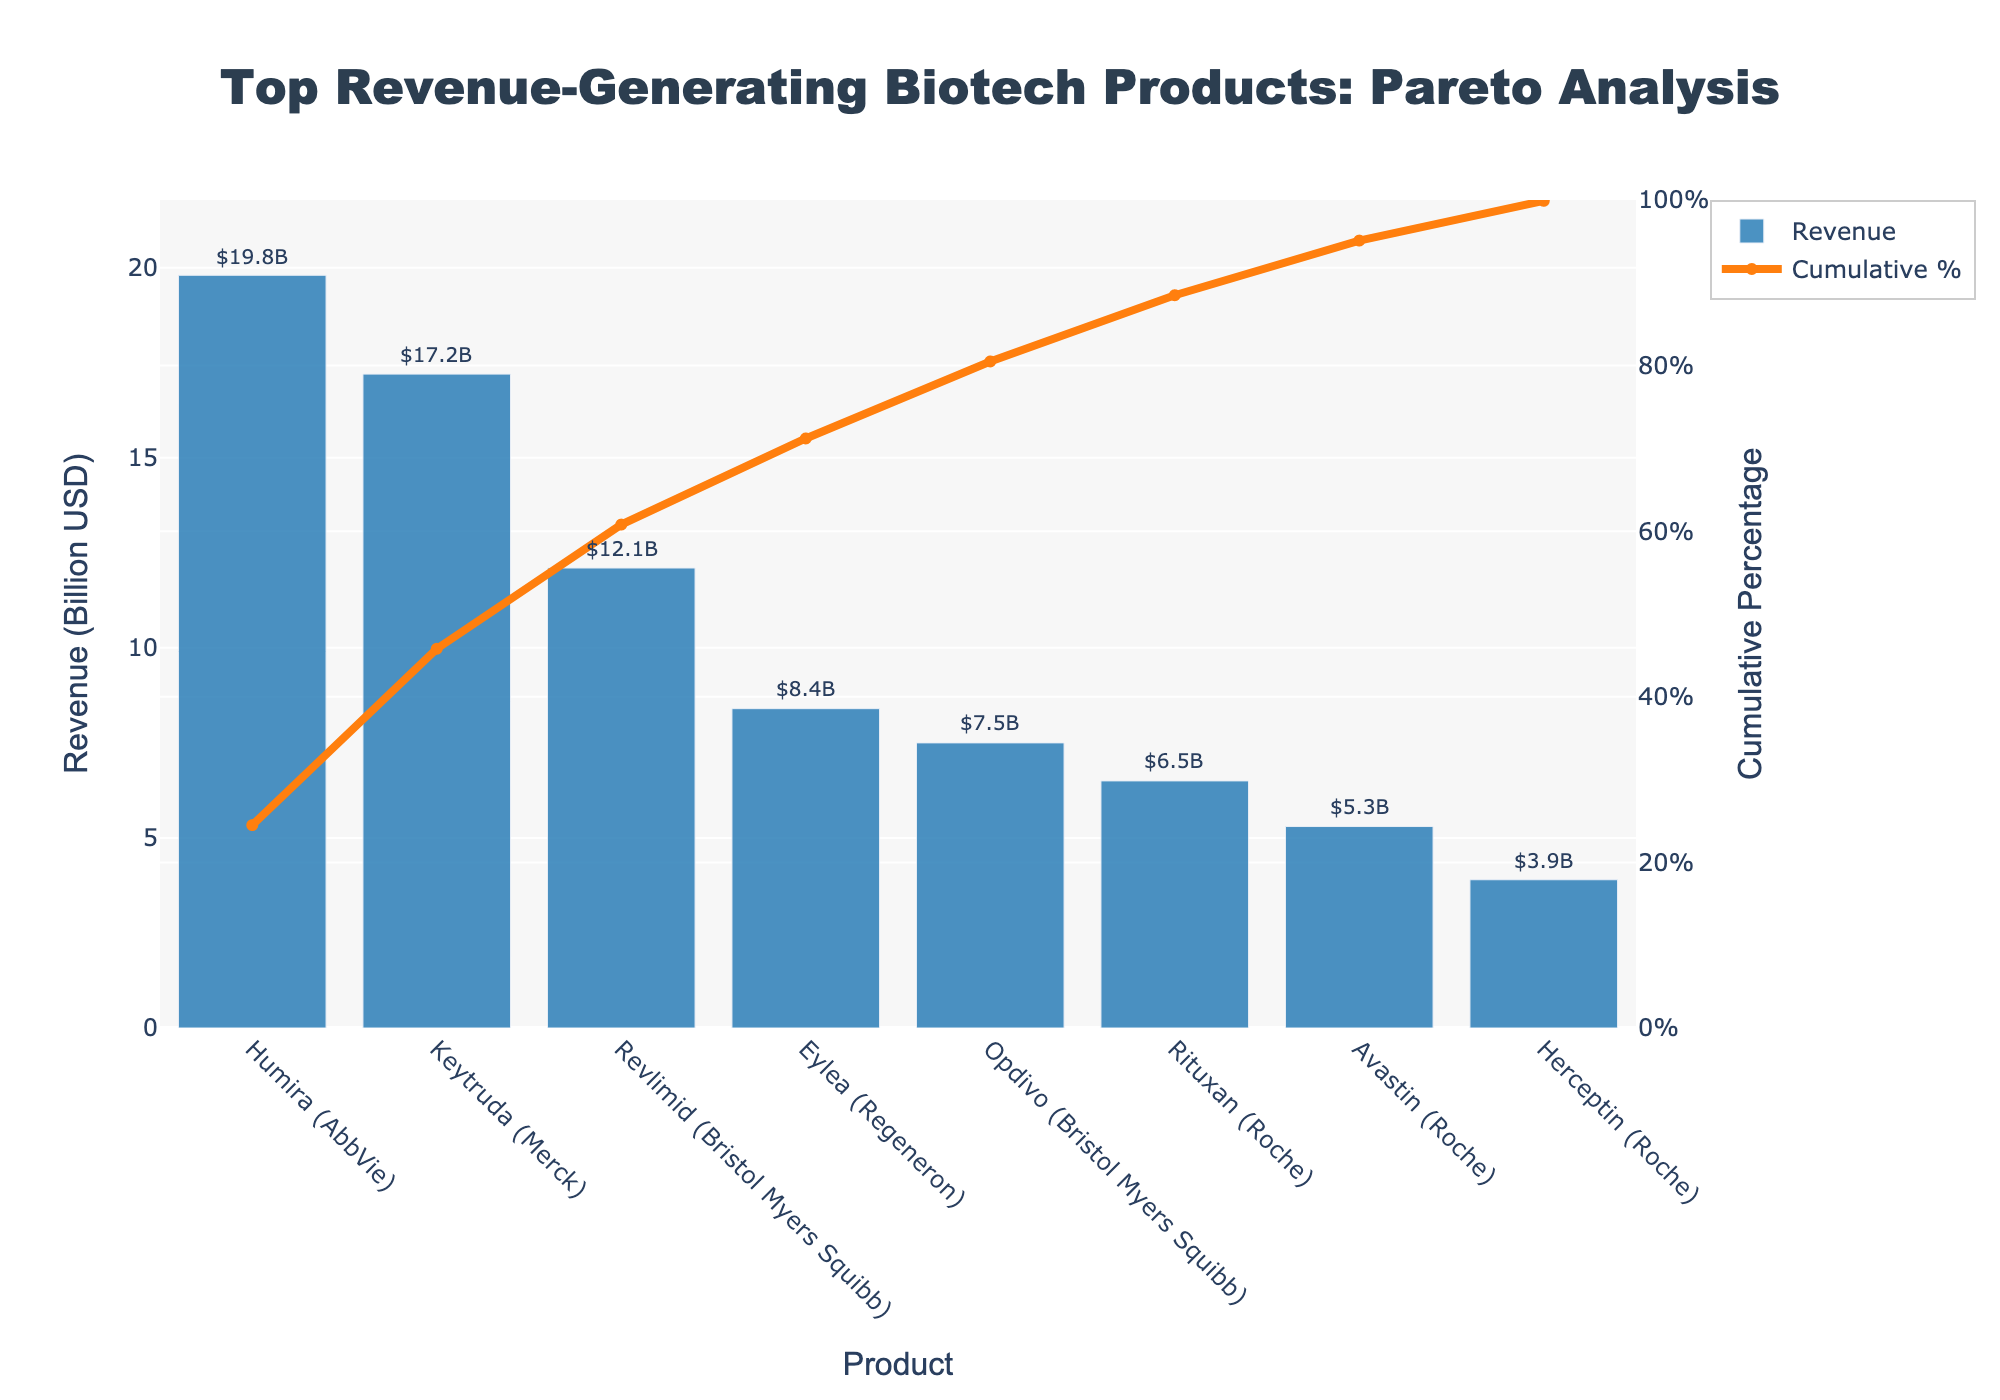How many biotech products are listed in the chart? Count the number of distinct products on the x-axis of the chart. Each product is represented by a bar on the chart.
Answer: 8 What is the revenue of Keytruda? Look at the height of the bar corresponding to Keytruda and the annotation above the bar, which indicates its revenue.
Answer: 17.2 Billion USD Which product has the highest revenue? The product with the highest revenue will have the tallest bar. Check the bar heights and annotations.
Answer: Humira What is the cumulative market share just after the fourth product? Sum the market shares of the first four products according to their order (Humira, Keytruda, Revlimid, Opdivo). This is also represented by the cumulative percentage line intersecting the fourth product.
Answer: 70.1% Which products together make up more than 50% of the market share? Starting from the leftmost product, sum their market shares until the total exceeds 50%. According to the cumulative percentage line, you can stop as soon as it exceeds 50%.
Answer: Humira and Keytruda What is the difference in revenue between the top revenue-generating product and the lowest revenue-generating product? Subtract the revenue of the product with the lowest revenue (Herceptin) from the revenue of the product with the highest revenue (Humira).
Answer: 15.9 Billion USD Which company has the most products listed in the chart? Count the number of products associated with each company by checking the product names and their corresponding companies in parentheses.
Answer: Roche How does the cumulative percentage change between Revlimid and Opdivo? Look at the cumulative percentage line and calculate the difference in the cumulative percentage values between Revlimid and Opdivo.
Answer: 9.3% Is there any product from Bristol Myers Squibb in the top three revenue-generating products? Check the names and revenues of the top three products (Humira, Keytruda, Revlimid) to see if any of them belong to Bristol Myers Squibb.
Answer: Yes What is the average revenue of Roche’s products listed in the chart? Add up the revenues of Roche's products (Rituxan, Avastin, Herceptin) and then divide by the number of products (3).
Answer: 5.23 Billion USD 